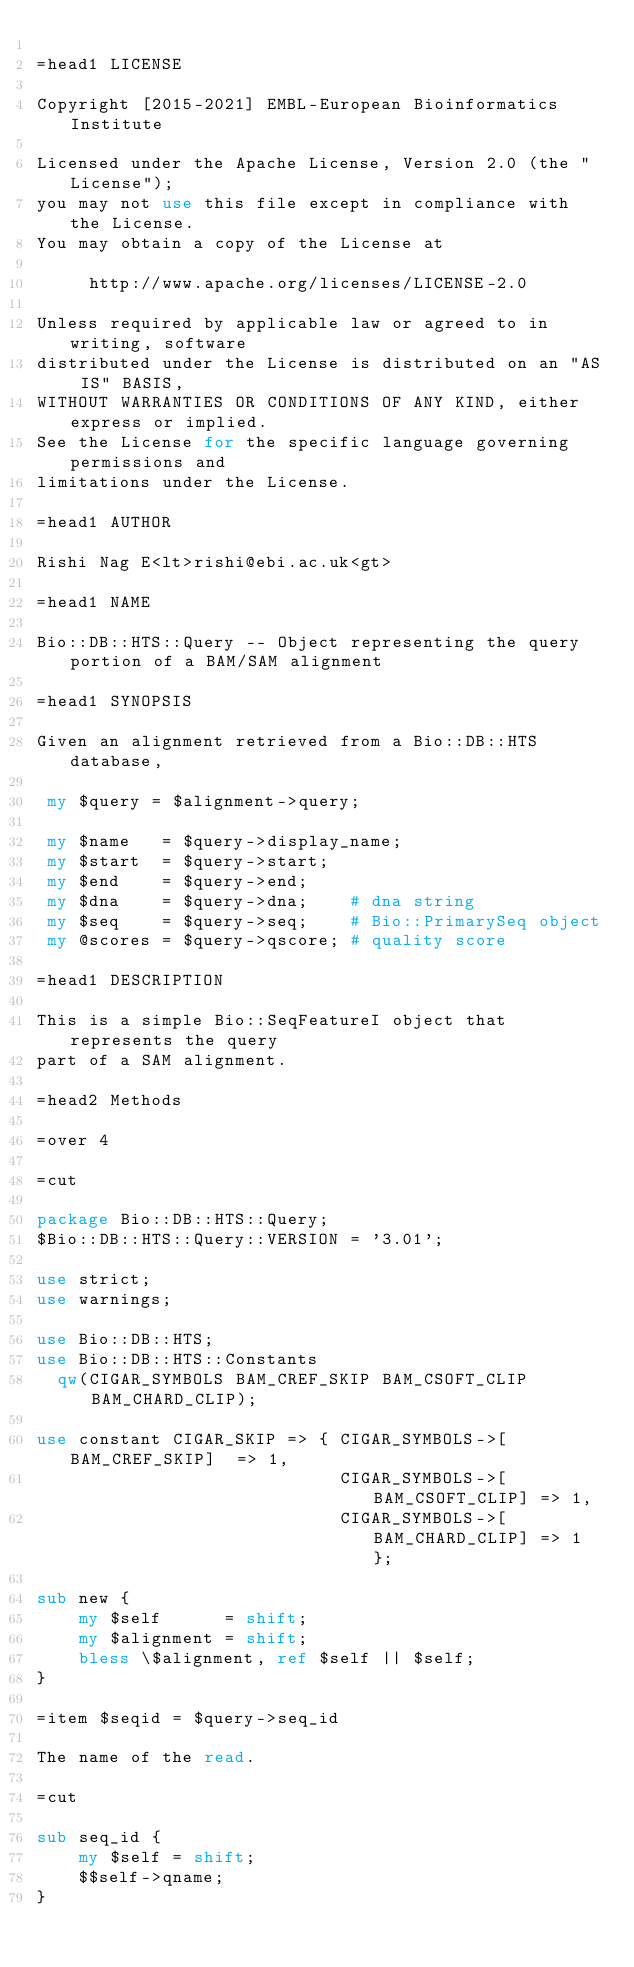Convert code to text. <code><loc_0><loc_0><loc_500><loc_500><_Perl_>
=head1 LICENSE

Copyright [2015-2021] EMBL-European Bioinformatics Institute

Licensed under the Apache License, Version 2.0 (the "License");
you may not use this file except in compliance with the License.
You may obtain a copy of the License at

     http://www.apache.org/licenses/LICENSE-2.0

Unless required by applicable law or agreed to in writing, software
distributed under the License is distributed on an "AS IS" BASIS,
WITHOUT WARRANTIES OR CONDITIONS OF ANY KIND, either express or implied.
See the License for the specific language governing permissions and
limitations under the License.

=head1 AUTHOR

Rishi Nag E<lt>rishi@ebi.ac.uk<gt>

=head1 NAME

Bio::DB::HTS::Query -- Object representing the query portion of a BAM/SAM alignment

=head1 SYNOPSIS

Given an alignment retrieved from a Bio::DB::HTS database,

 my $query = $alignment->query;

 my $name   = $query->display_name;
 my $start  = $query->start;
 my $end    = $query->end;
 my $dna    = $query->dna;    # dna string
 my $seq    = $query->seq;    # Bio::PrimarySeq object
 my @scores = $query->qscore; # quality score

=head1 DESCRIPTION

This is a simple Bio::SeqFeatureI object that represents the query
part of a SAM alignment.

=head2 Methods

=over 4

=cut

package Bio::DB::HTS::Query;
$Bio::DB::HTS::Query::VERSION = '3.01';

use strict;
use warnings;

use Bio::DB::HTS;
use Bio::DB::HTS::Constants
  qw(CIGAR_SYMBOLS BAM_CREF_SKIP BAM_CSOFT_CLIP BAM_CHARD_CLIP);

use constant CIGAR_SKIP => { CIGAR_SYMBOLS->[BAM_CREF_SKIP]  => 1,
                             CIGAR_SYMBOLS->[BAM_CSOFT_CLIP] => 1,
                             CIGAR_SYMBOLS->[BAM_CHARD_CLIP] => 1 };

sub new {
    my $self      = shift;
    my $alignment = shift;
    bless \$alignment, ref $self || $self;
}

=item $seqid = $query->seq_id

The name of the read.

=cut

sub seq_id {
    my $self = shift;
    $$self->qname;
}
</code> 